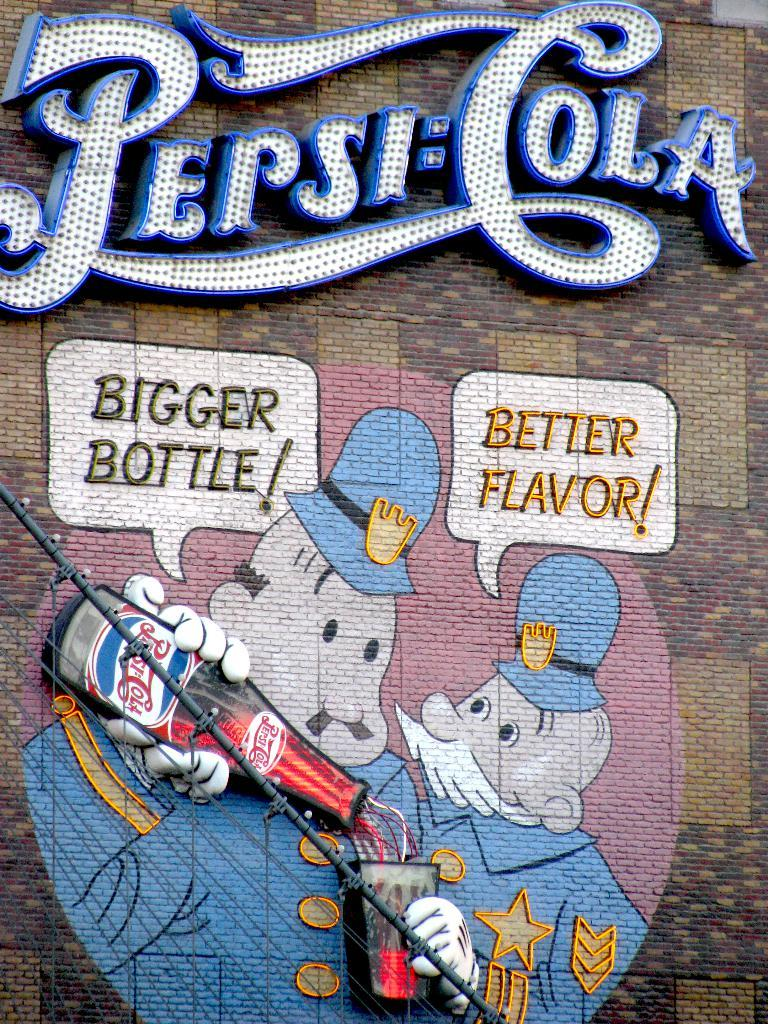What is present on the wall in the image? There are name boards and a painting on the wall in the image. Can you describe the painting on the wall? Unfortunately, the facts provided do not give a description of the painting. How many name boards are placed on the wall? The facts provided do not specify the number of name boards on the wall. Reasoning: Let's no need to mention the absurd topics in this case, as they are not relevant to the given facts. We start by identifying the main subjects on the wall, which are the name boards and the painting. Then, we formulate questions that focus on these subjects, ensuring that each question can be answered definitively with the information given. We avoid yes/no questions and ensure that the language is simple and clear. Absurd Question/Answer: Is there a basketball hoop visible in the image? There is no mention of a basketball hoop or any sports equipment in the provided facts, so it cannot be determined from the image. How much waste is being recycled in the image? There is no mention of waste or recycling in the provided facts, so it cannot be determined from the image. 